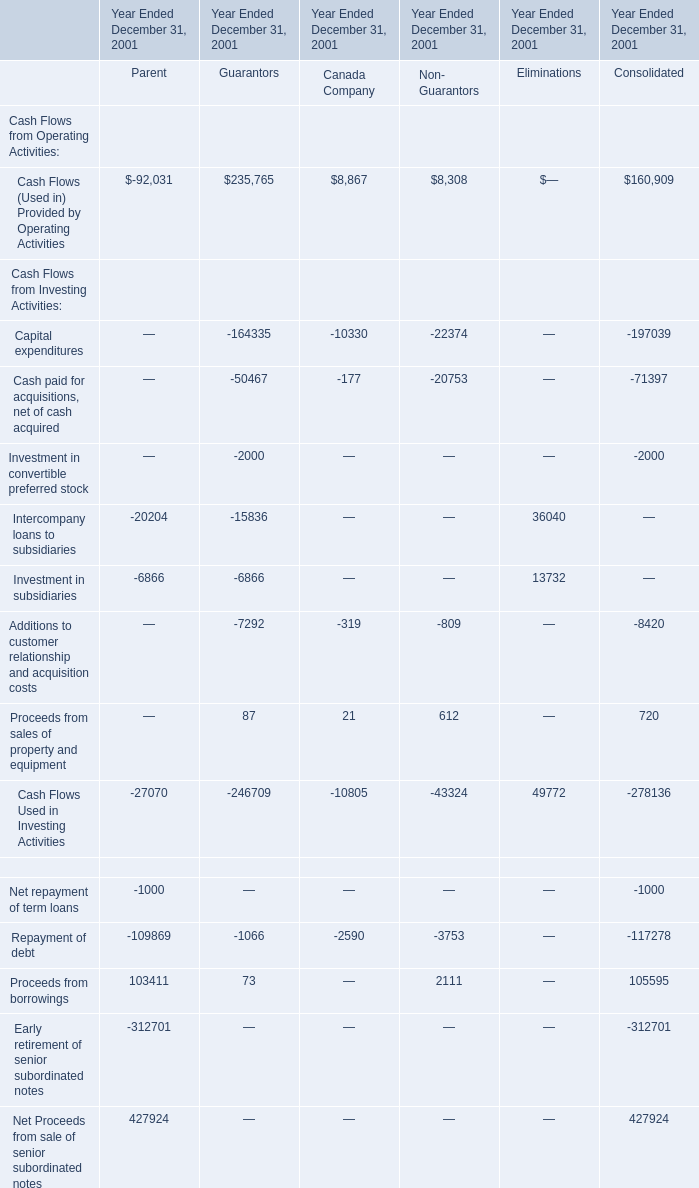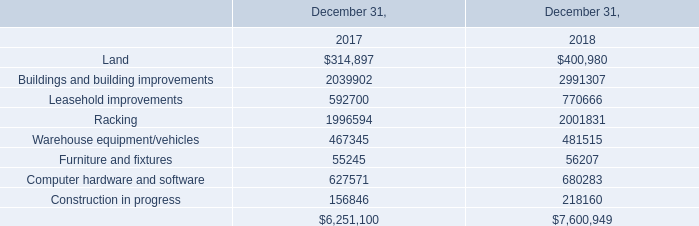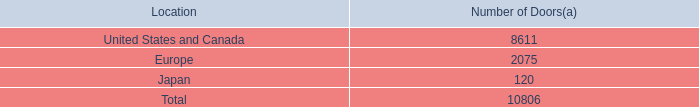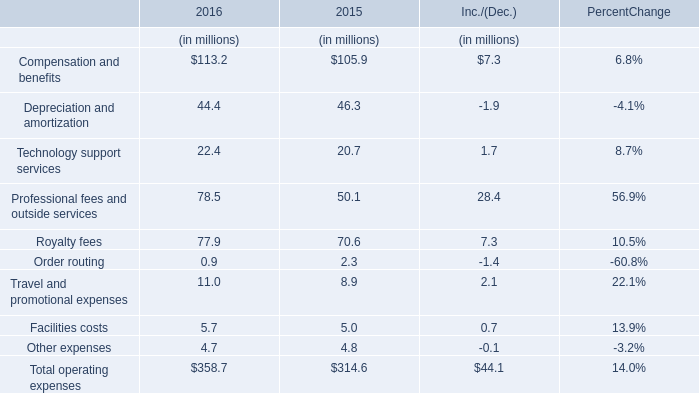What will Royalty fees be like in 2017 if it develops with the same increasing rate as current? (in million) 
Computations: ((((77.9 - 70.6) / 70.6) + 1) * 77.9)
Answer: 85.95482. 